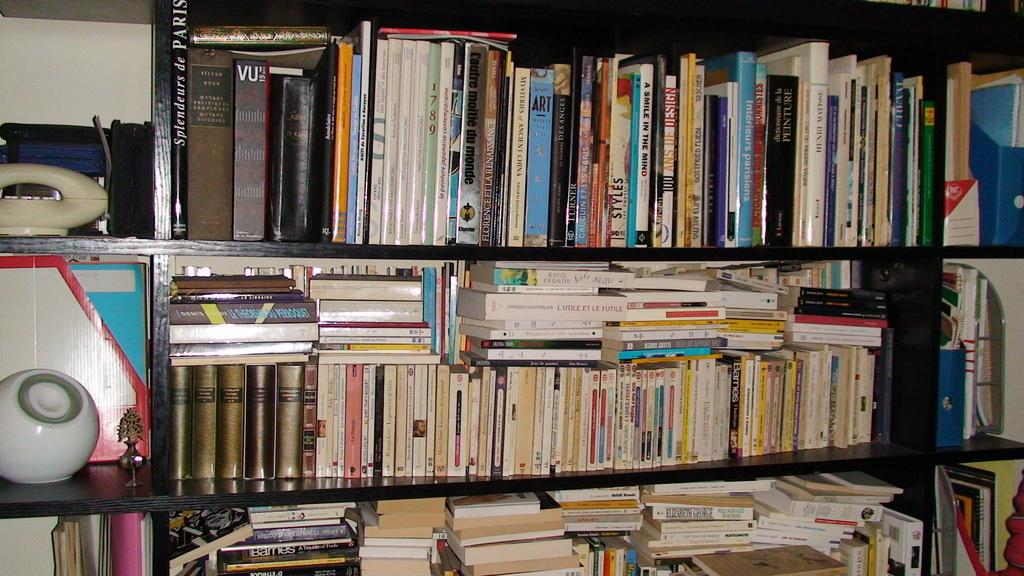What type of items can be seen in the image? There are books in the image. Where are the books located? The books are placed on book shelves. Are there any other objects visible in the image? Yes, there are other objects in the left corner of the image. What type of comfort can be seen in the image? There is no specific comfort visible in the image; it primarily features books on book shelves and other objects in the left corner. 